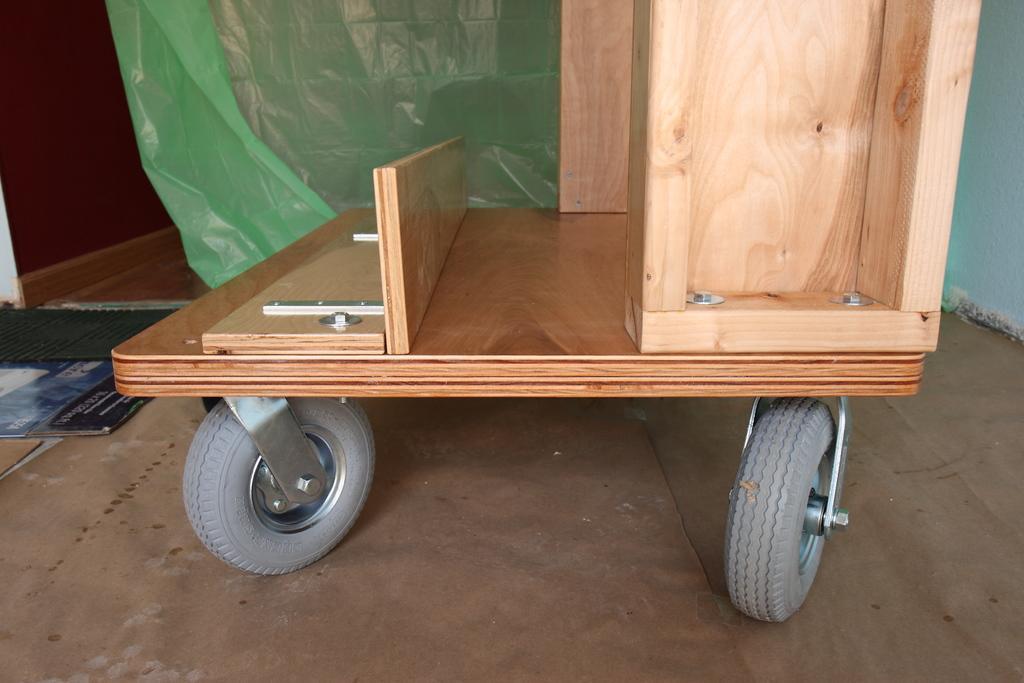How would you summarize this image in a sentence or two? In this image I can see the wooden trolley. In the background I can see the cover in green color and the wall is in blue color. 